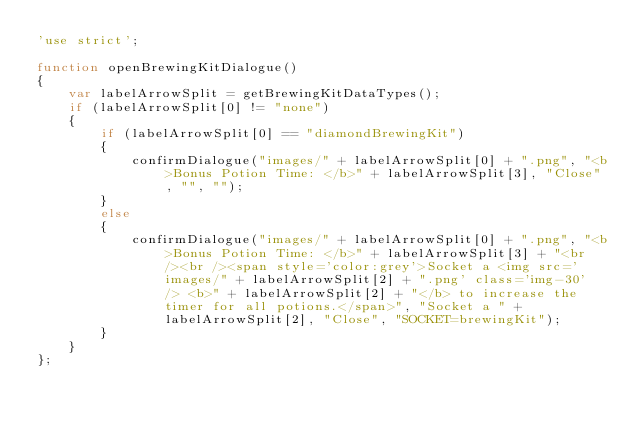Convert code to text. <code><loc_0><loc_0><loc_500><loc_500><_JavaScript_>'use strict';

function openBrewingKitDialogue()
{
	var labelArrowSplit = getBrewingKitDataTypes();
	if (labelArrowSplit[0] != "none")
	{
		if (labelArrowSplit[0] == "diamondBrewingKit")
		{
			confirmDialogue("images/" + labelArrowSplit[0] + ".png", "<b>Bonus Potion Time: </b>" + labelArrowSplit[3], "Close", "", "");
		}
		else
		{
			confirmDialogue("images/" + labelArrowSplit[0] + ".png", "<b>Bonus Potion Time: </b>" + labelArrowSplit[3] + "<br /><br /><span style='color:grey'>Socket a <img src='images/" + labelArrowSplit[2] + ".png' class='img-30' /> <b>" + labelArrowSplit[2] + "</b> to increase the timer for all potions.</span>", "Socket a " + labelArrowSplit[2], "Close", "SOCKET=brewingKit");
		}
	}
};
</code> 